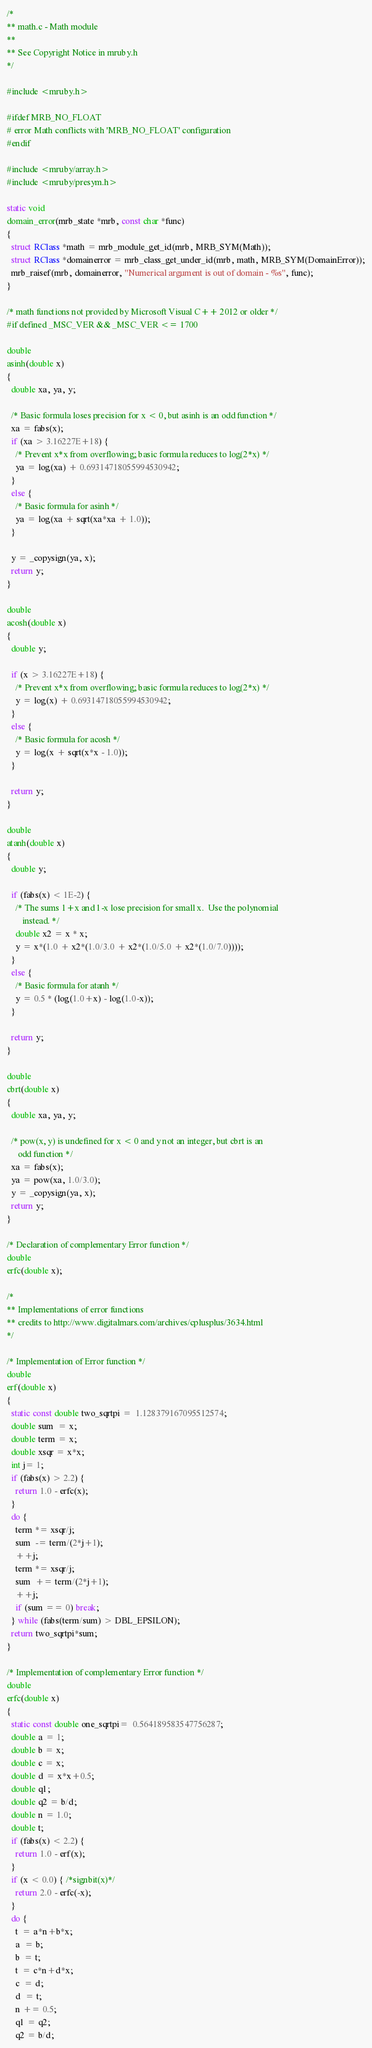Convert code to text. <code><loc_0><loc_0><loc_500><loc_500><_C_>/*
** math.c - Math module
**
** See Copyright Notice in mruby.h
*/

#include <mruby.h>

#ifdef MRB_NO_FLOAT
# error Math conflicts with 'MRB_NO_FLOAT' configuration
#endif

#include <mruby/array.h>
#include <mruby/presym.h>

static void
domain_error(mrb_state *mrb, const char *func)
{
  struct RClass *math = mrb_module_get_id(mrb, MRB_SYM(Math));
  struct RClass *domainerror = mrb_class_get_under_id(mrb, math, MRB_SYM(DomainError));
  mrb_raisef(mrb, domainerror, "Numerical argument is out of domain - %s", func);
}

/* math functions not provided by Microsoft Visual C++ 2012 or older */
#if defined _MSC_VER && _MSC_VER <= 1700

double
asinh(double x)
{
  double xa, ya, y;

  /* Basic formula loses precision for x < 0, but asinh is an odd function */
  xa = fabs(x);
  if (xa > 3.16227E+18) {
    /* Prevent x*x from overflowing; basic formula reduces to log(2*x) */
    ya = log(xa) + 0.69314718055994530942;
  }
  else {
    /* Basic formula for asinh */
    ya = log(xa + sqrt(xa*xa + 1.0));
  }

  y = _copysign(ya, x);
  return y;
}

double
acosh(double x)
{
  double y;

  if (x > 3.16227E+18) {
    /* Prevent x*x from overflowing; basic formula reduces to log(2*x) */
    y = log(x) + 0.69314718055994530942;
  }
  else {
    /* Basic formula for acosh */
    y = log(x + sqrt(x*x - 1.0));
  }

  return y;
}

double
atanh(double x)
{
  double y;

  if (fabs(x) < 1E-2) {
    /* The sums 1+x and 1-x lose precision for small x.  Use the polynomial
       instead. */
    double x2 = x * x;
    y = x*(1.0 + x2*(1.0/3.0 + x2*(1.0/5.0 + x2*(1.0/7.0))));
  }
  else {
    /* Basic formula for atanh */
    y = 0.5 * (log(1.0+x) - log(1.0-x));
  }

  return y;
}

double
cbrt(double x)
{
  double xa, ya, y;

  /* pow(x, y) is undefined for x < 0 and y not an integer, but cbrt is an
     odd function */
  xa = fabs(x);
  ya = pow(xa, 1.0/3.0);
  y = _copysign(ya, x);
  return y;
}

/* Declaration of complementary Error function */
double
erfc(double x);

/*
** Implementations of error functions
** credits to http://www.digitalmars.com/archives/cplusplus/3634.html
*/

/* Implementation of Error function */
double
erf(double x)
{
  static const double two_sqrtpi =  1.128379167095512574;
  double sum  = x;
  double term = x;
  double xsqr = x*x;
  int j= 1;
  if (fabs(x) > 2.2) {
    return 1.0 - erfc(x);
  }
  do {
    term *= xsqr/j;
    sum  -= term/(2*j+1);
    ++j;
    term *= xsqr/j;
    sum  += term/(2*j+1);
    ++j;
    if (sum == 0) break;
  } while (fabs(term/sum) > DBL_EPSILON);
  return two_sqrtpi*sum;
}

/* Implementation of complementary Error function */
double
erfc(double x)
{
  static const double one_sqrtpi=  0.564189583547756287;
  double a = 1;
  double b = x;
  double c = x;
  double d = x*x+0.5;
  double q1;
  double q2 = b/d;
  double n = 1.0;
  double t;
  if (fabs(x) < 2.2) {
    return 1.0 - erf(x);
  }
  if (x < 0.0) { /*signbit(x)*/
    return 2.0 - erfc(-x);
  }
  do {
    t  = a*n+b*x;
    a  = b;
    b  = t;
    t  = c*n+d*x;
    c  = d;
    d  = t;
    n += 0.5;
    q1 = q2;
    q2 = b/d;</code> 